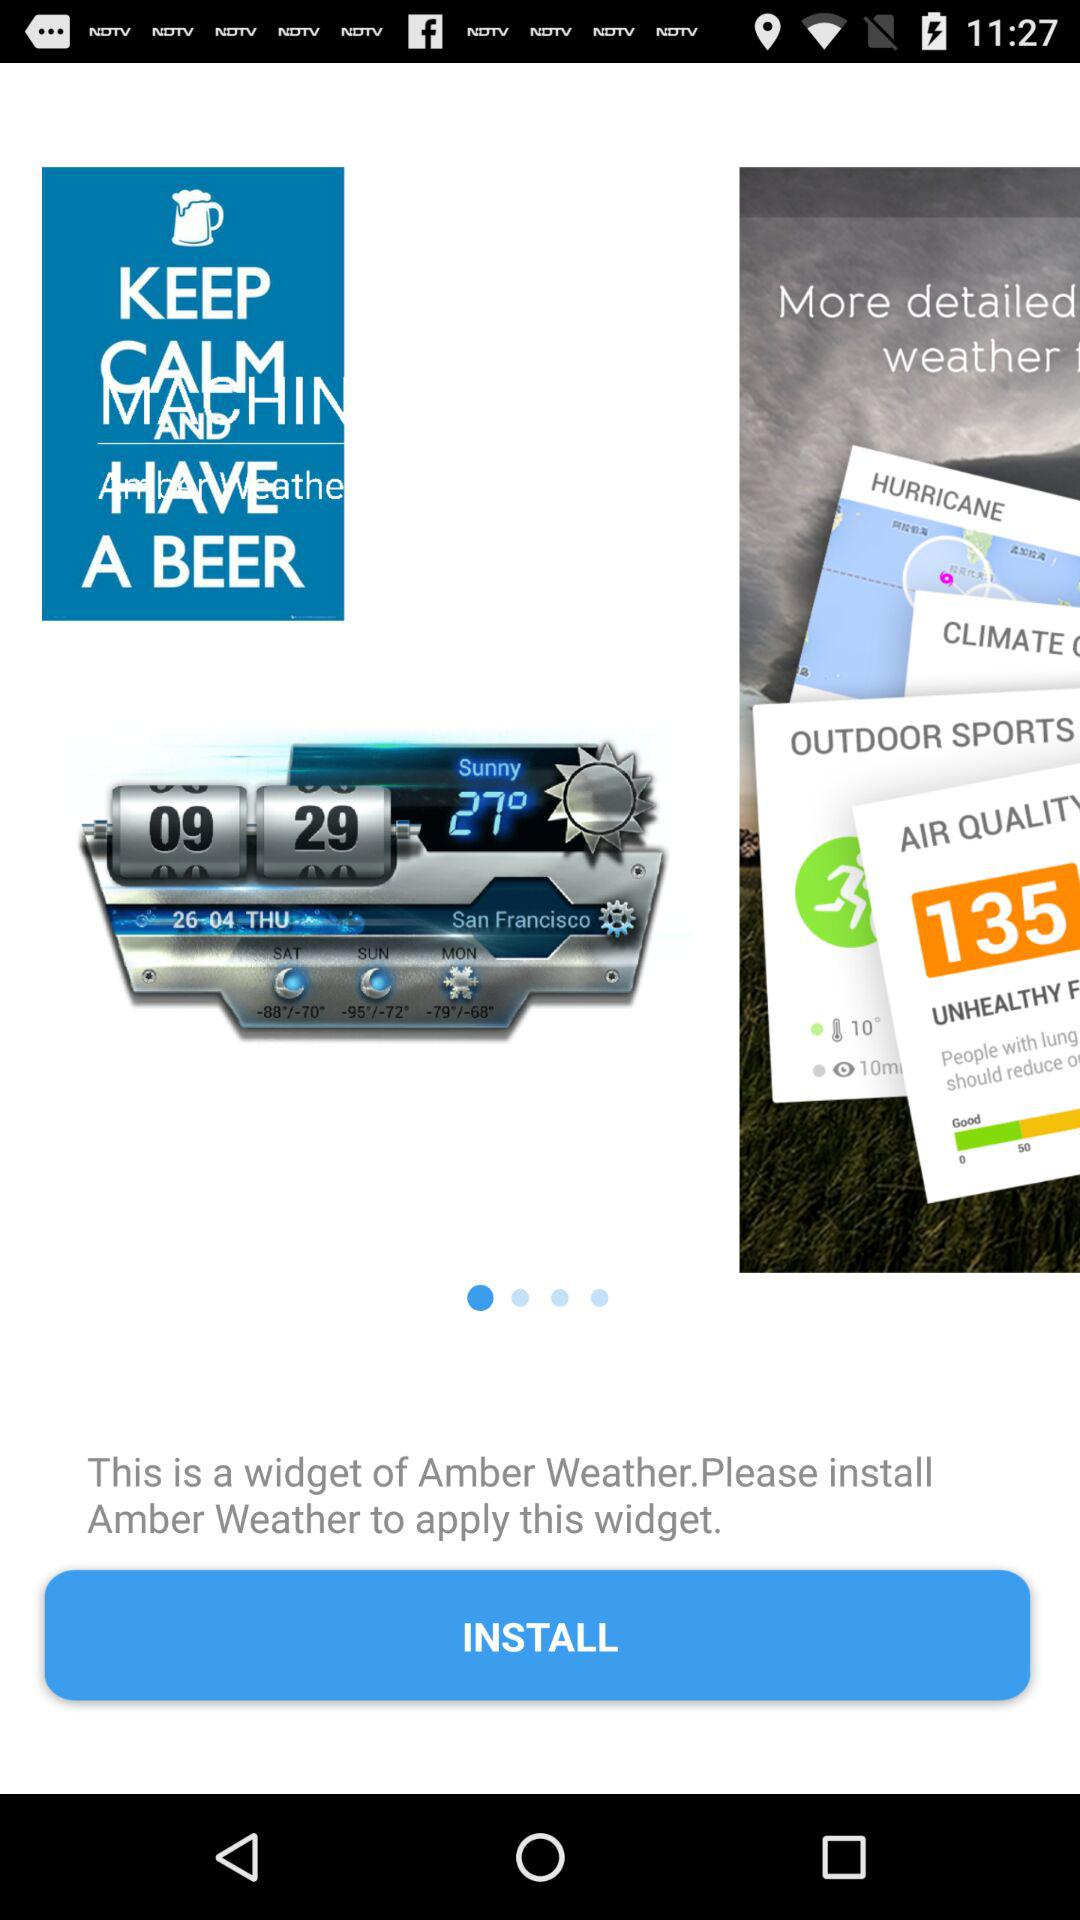What is the year?
When the provided information is insufficient, respond with <no answer>. <no answer> 